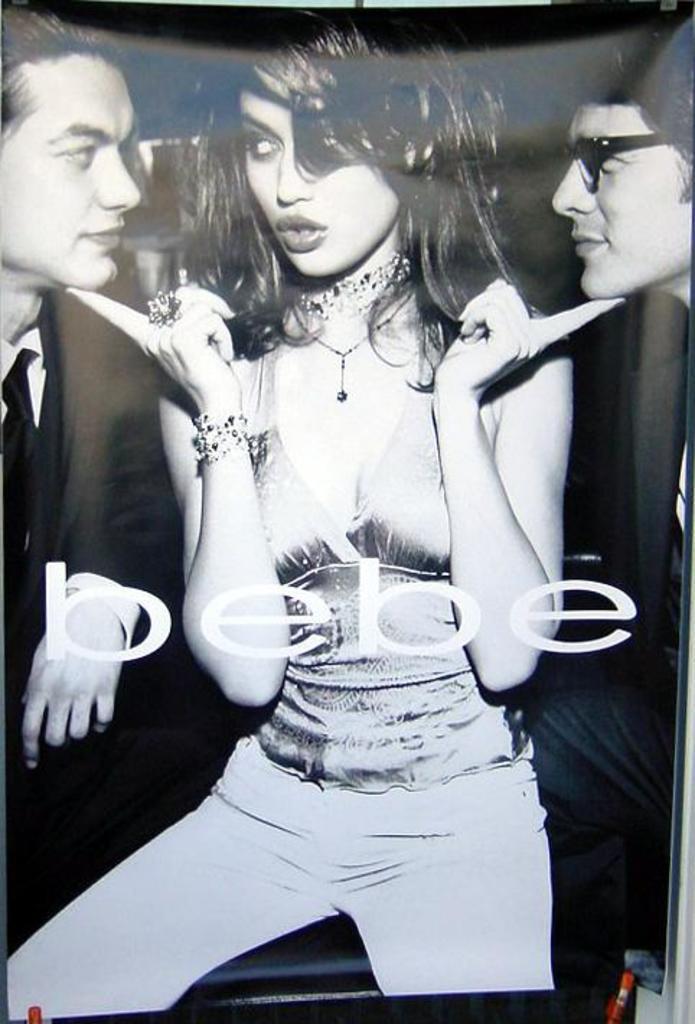Please provide a concise description of this image. It is a black and white image. In this image we can see a poster with the woman and also two men. We can also see the text. 